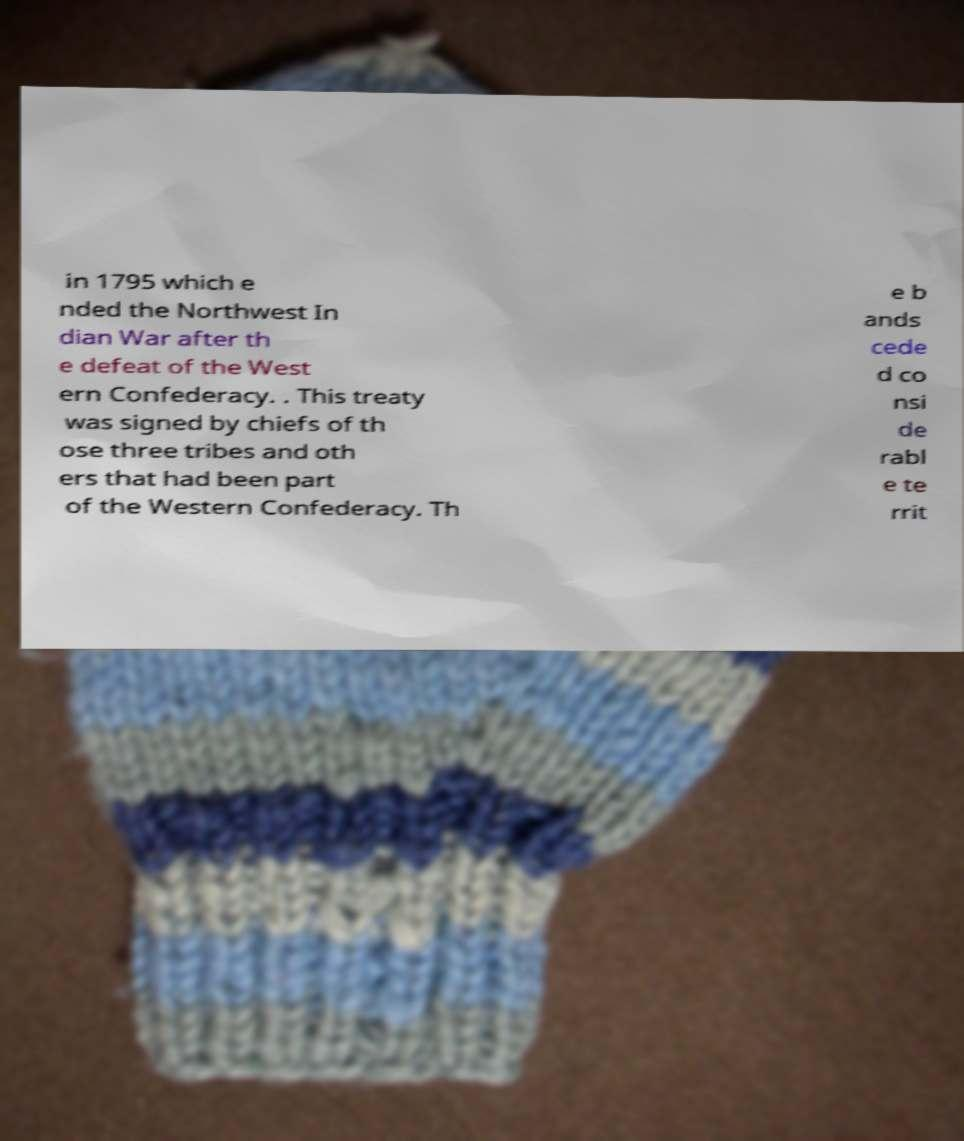For documentation purposes, I need the text within this image transcribed. Could you provide that? in 1795 which e nded the Northwest In dian War after th e defeat of the West ern Confederacy. . This treaty was signed by chiefs of th ose three tribes and oth ers that had been part of the Western Confederacy. Th e b ands cede d co nsi de rabl e te rrit 